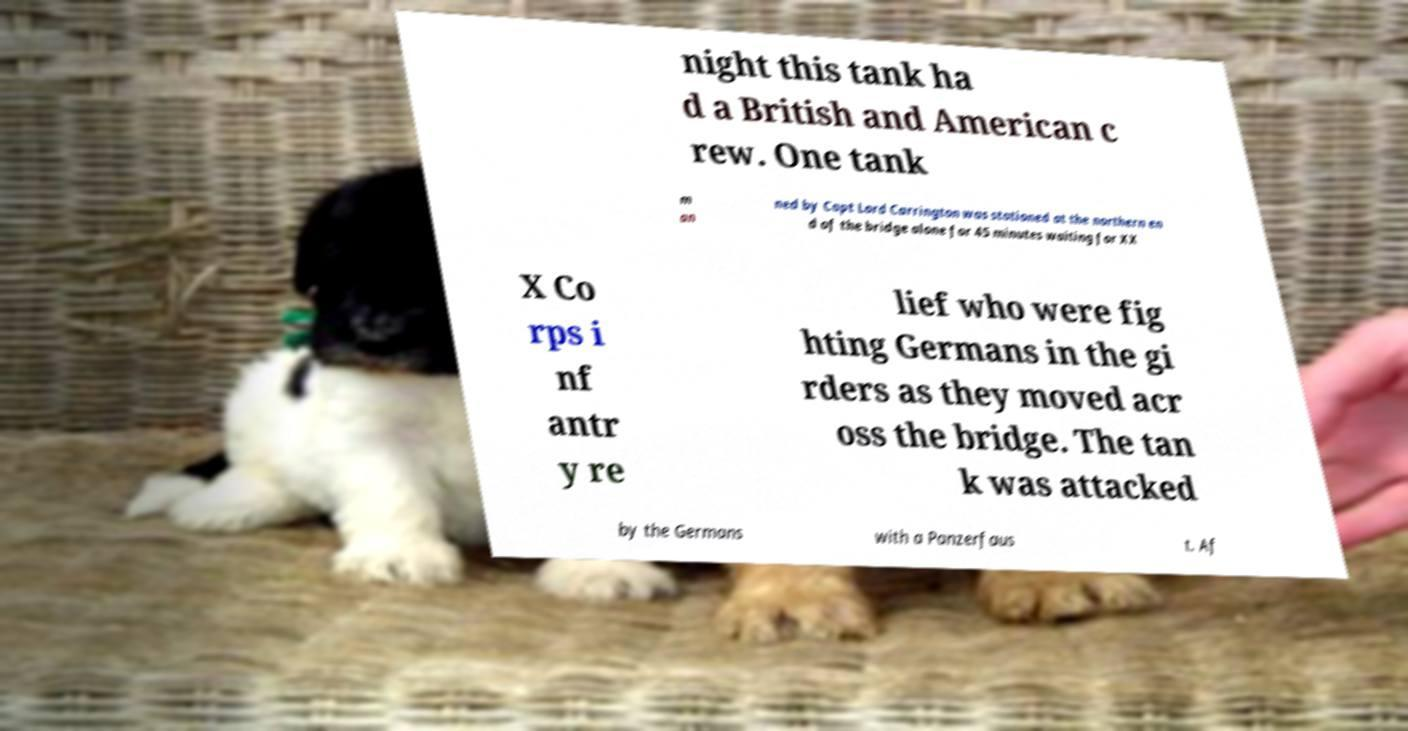Could you assist in decoding the text presented in this image and type it out clearly? night this tank ha d a British and American c rew. One tank m an ned by Capt Lord Carrington was stationed at the northern en d of the bridge alone for 45 minutes waiting for XX X Co rps i nf antr y re lief who were fig hting Germans in the gi rders as they moved acr oss the bridge. The tan k was attacked by the Germans with a Panzerfaus t. Af 